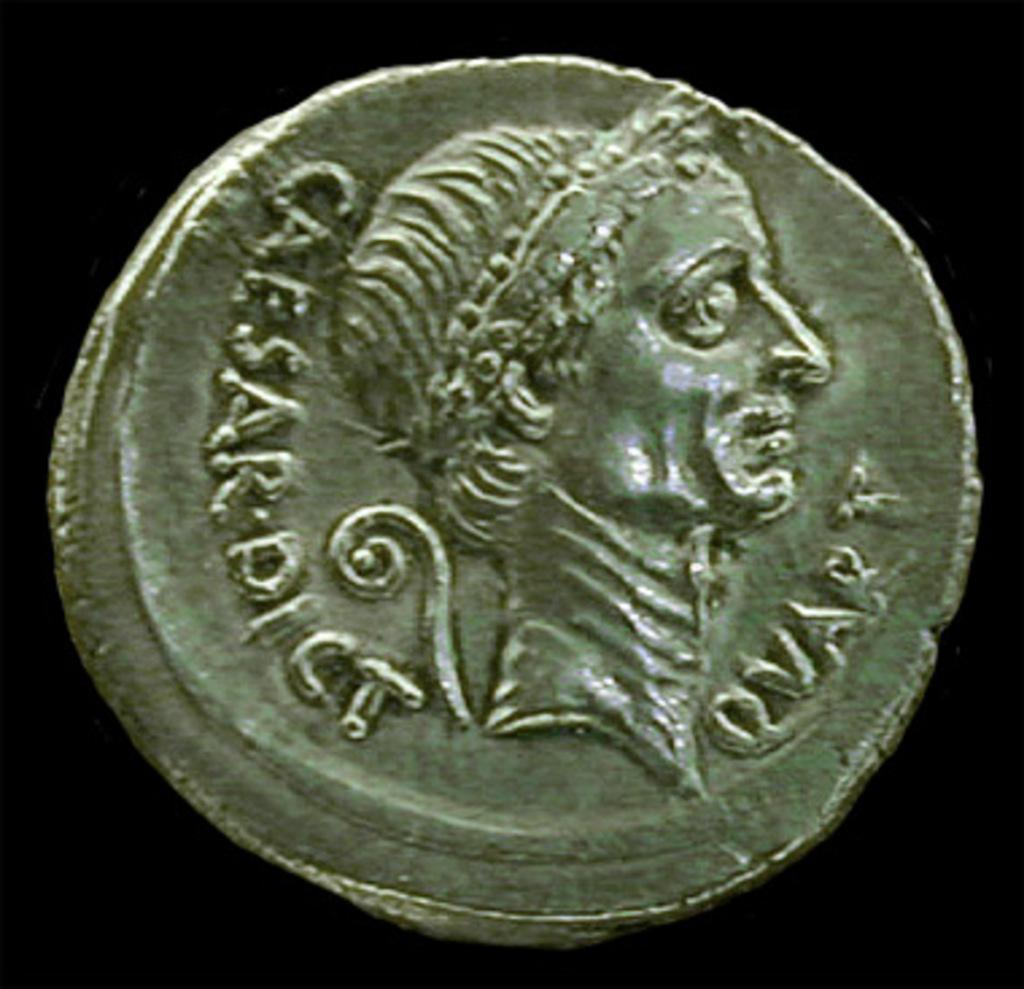<image>
Render a clear and concise summary of the photo. An old Roman coin imprinted with "Caesar Dict" 